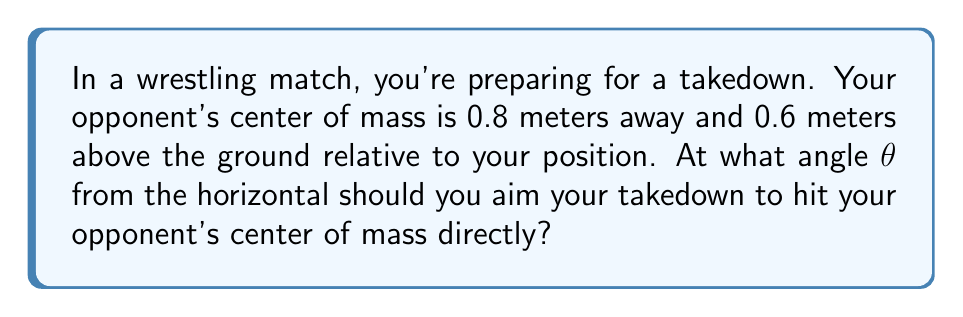Solve this math problem. Let's approach this step-by-step using trigonometry:

1) We can visualize this as a right triangle, where:
   - The horizontal distance to the opponent is the adjacent side (0.8 m)
   - The vertical distance to the opponent's center of mass is the opposite side (0.6 m)
   - The line of your takedown is the hypotenuse
   - The angle we're looking for (θ) is between the horizontal and the hypotenuse

2) In this scenario, we can use the tangent function, which is defined as:

   $$\tan θ = \frac{\text{opposite}}{\text{adjacent}}$$

3) Plugging in our known values:

   $$\tan θ = \frac{0.6}{0.8}$$

4) Simplify:
   
   $$\tan θ = 0.75$$

5) To find θ, we need to use the inverse tangent (arctangent) function:

   $$θ = \arctan(0.75)$$

6) Using a calculator or trigonometric tables:

   $$θ ≈ 36.87°$$

7) Round to the nearest degree:

   $$θ ≈ 37°$$

This angle will ensure your takedown trajectory aims directly at your opponent's center of mass.

[asy]
import geometry;

size(200);
draw((0,0)--(8,0), arrow=Arrow(TeXHead));
draw((0,0)--(0,6), arrow=Arrow(TeXHead));
draw((0,0)--(8,6), arrow=Arrow(TeXHead));

label("0.8 m", (4,0), S);
label("0.6 m", (8,3), E);
label("$θ$", (1,0.5), NW);

dot((8,6));
label("Opponent's CM", (8,6), NE);
[/asy]
Answer: $37°$ 